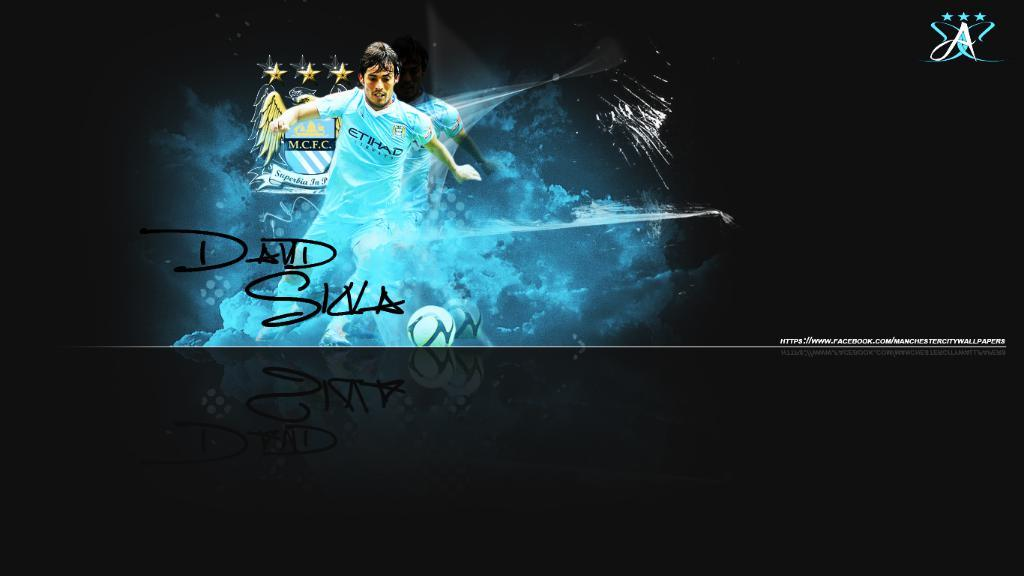What is the main subject of the image? There is a person in the image. What is the person doing in the image? The person is playing with a football. How many eyes does the scarecrow have in the image? There is no scarecrow present in the image, so it is not possible to determine the number of eyes it might have. 